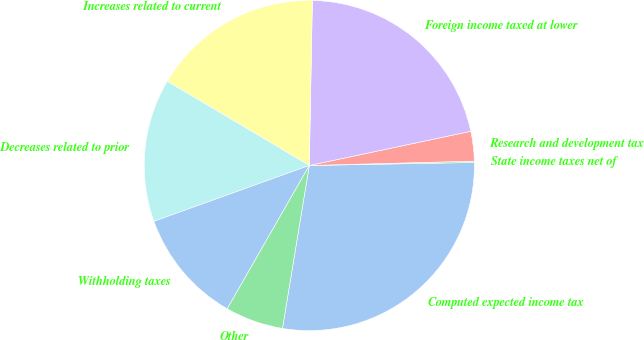<chart> <loc_0><loc_0><loc_500><loc_500><pie_chart><fcel>Computed expected income tax<fcel>State income taxes net of<fcel>Research and development tax<fcel>Foreign income taxed at lower<fcel>Increases related to current<fcel>Decreases related to prior<fcel>Withholding taxes<fcel>Other<nl><fcel>27.89%<fcel>0.13%<fcel>2.9%<fcel>21.38%<fcel>16.78%<fcel>14.01%<fcel>11.23%<fcel>5.68%<nl></chart> 